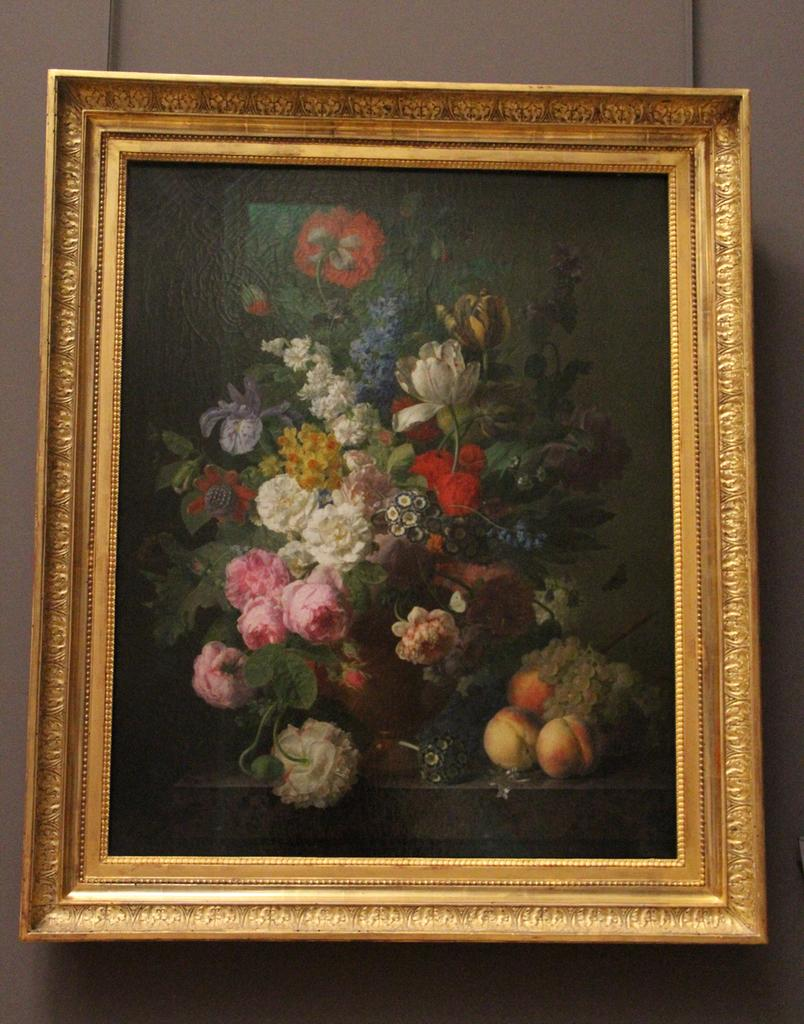What is the main subject of the image? The main subject of the image is a frame. What is inside the frame? The frame contains colorful flowers and fruits. How many passengers are visible in the image? There are no passengers present in the image; it features a frame with flowers and fruits. What type of jam is being made in the image? There is no jam-making process depicted in the image; it features a frame with flowers and fruits. 